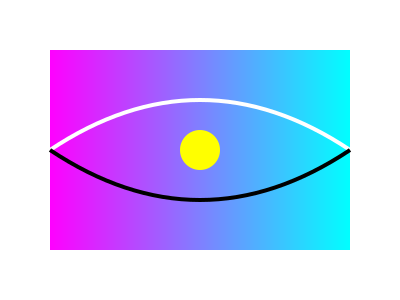In the abstract representation of time dilation above, what does the curved white line symbolize compared to the black line, and how does this relate to the concept of time dilation in futuristic visual art? 1. The image uses abstract elements to represent time dilation:
   - The gradient background represents the flow of time and space.
   - The curved lines represent different time paths.
   - The yellow circle symbolizes an object or observer.

2. The white curved line is positioned above the black line, suggesting a shorter path between two points.

3. In the context of time dilation:
   - The white line represents time as experienced by an object moving at high velocity.
   - The black line represents time as experienced by a stationary observer.

4. Time dilation theory states that time moves slower for objects moving at high speeds relative to stationary observers.

5. In futuristic visual art, this concept can be illustrated by:
   - Using curved or distorted lines to show the bending of spacetime.
   - Contrasting colors or shapes to differentiate between different time experiences.
   - Gradients or blurred elements to suggest the fluidity and relativity of time.

6. The abstract nature of the image allows artists to explore complex scientific concepts through visual metaphors, which is a key aspect of futuristic aesthetic in visual art.
Answer: The white line represents accelerated time passage for fast-moving objects, while the black line shows normal time flow, illustrating time dilation through abstract visual metaphors in futuristic art. 